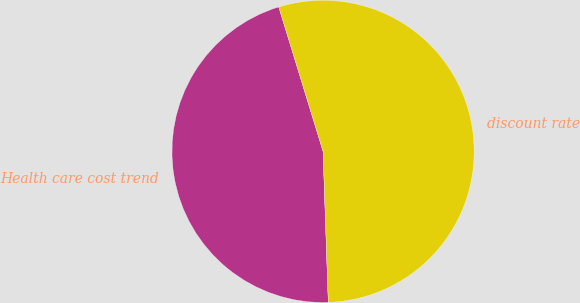Convert chart to OTSL. <chart><loc_0><loc_0><loc_500><loc_500><pie_chart><fcel>Health care cost trend<fcel>discount rate<nl><fcel>45.81%<fcel>54.19%<nl></chart> 